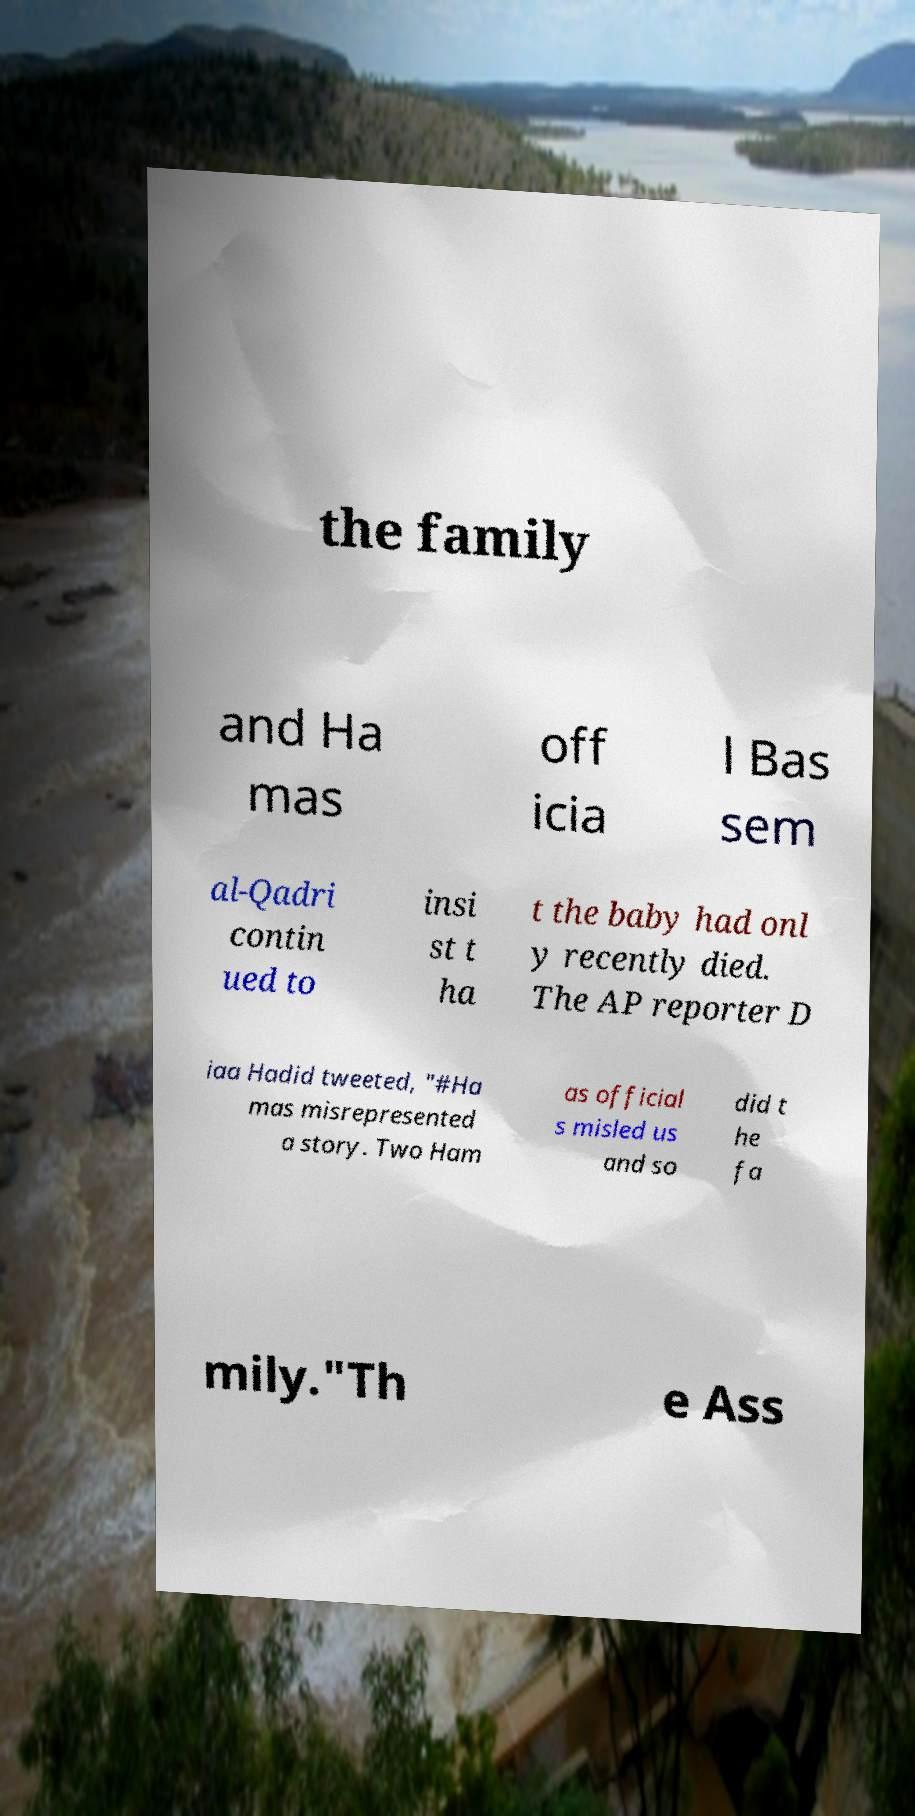Could you extract and type out the text from this image? the family and Ha mas off icia l Bas sem al-Qadri contin ued to insi st t ha t the baby had onl y recently died. The AP reporter D iaa Hadid tweeted, "#Ha mas misrepresented a story. Two Ham as official s misled us and so did t he fa mily."Th e Ass 